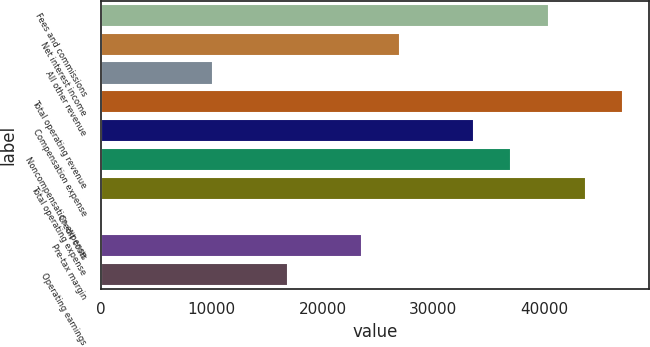Convert chart. <chart><loc_0><loc_0><loc_500><loc_500><bar_chart><fcel>Fees and commissions<fcel>Net interest income<fcel>All other revenue<fcel>Total operating revenue<fcel>Compensation expense<fcel>Noncompensation expense<fcel>Total operating expense<fcel>Credit costs<fcel>Pre-tax margin<fcel>Operating earnings<nl><fcel>40415<fcel>26955<fcel>10130<fcel>47145<fcel>33685<fcel>37050<fcel>43780<fcel>35<fcel>23590<fcel>16860<nl></chart> 